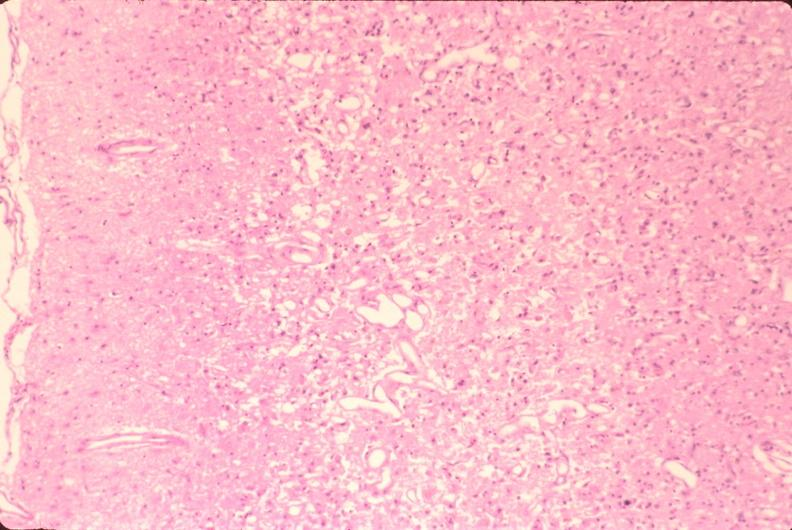what is present?
Answer the question using a single word or phrase. Nervous 